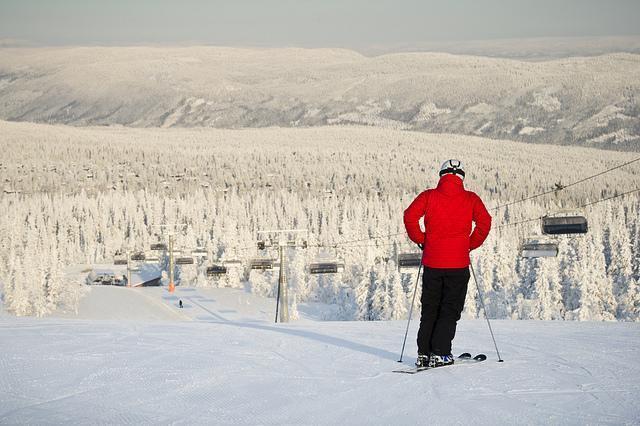What type of sport is he practicing?
Pick the correct solution from the four options below to address the question.
Options: Team, winter, aquatic, combat. Winter. 